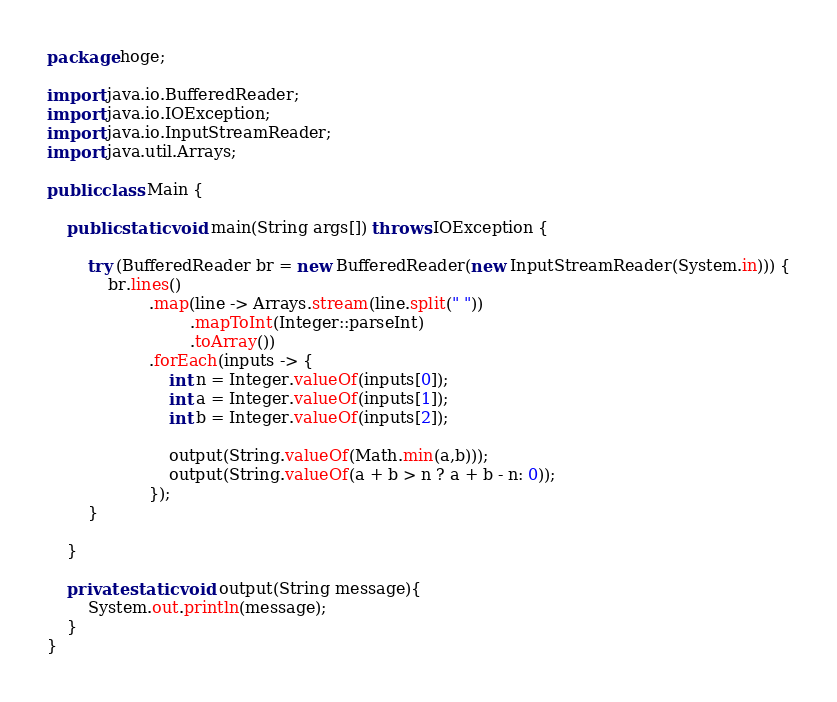Convert code to text. <code><loc_0><loc_0><loc_500><loc_500><_Java_>package hoge;

import java.io.BufferedReader;
import java.io.IOException;
import java.io.InputStreamReader;
import java.util.Arrays;

public class Main {

    public static void main(String args[]) throws IOException {

        try (BufferedReader br = new BufferedReader(new InputStreamReader(System.in))) {
            br.lines()
                    .map(line -> Arrays.stream(line.split(" "))
                            .mapToInt(Integer::parseInt)
                            .toArray())
                    .forEach(inputs -> {
                        int n = Integer.valueOf(inputs[0]);
                        int a = Integer.valueOf(inputs[1]);
                        int b = Integer.valueOf(inputs[2]);

                        output(String.valueOf(Math.min(a,b)));
                        output(String.valueOf(a + b > n ? a + b - n: 0));
                    });
        }

    }

    private static void output(String message){
        System.out.println(message);
    }
}
</code> 